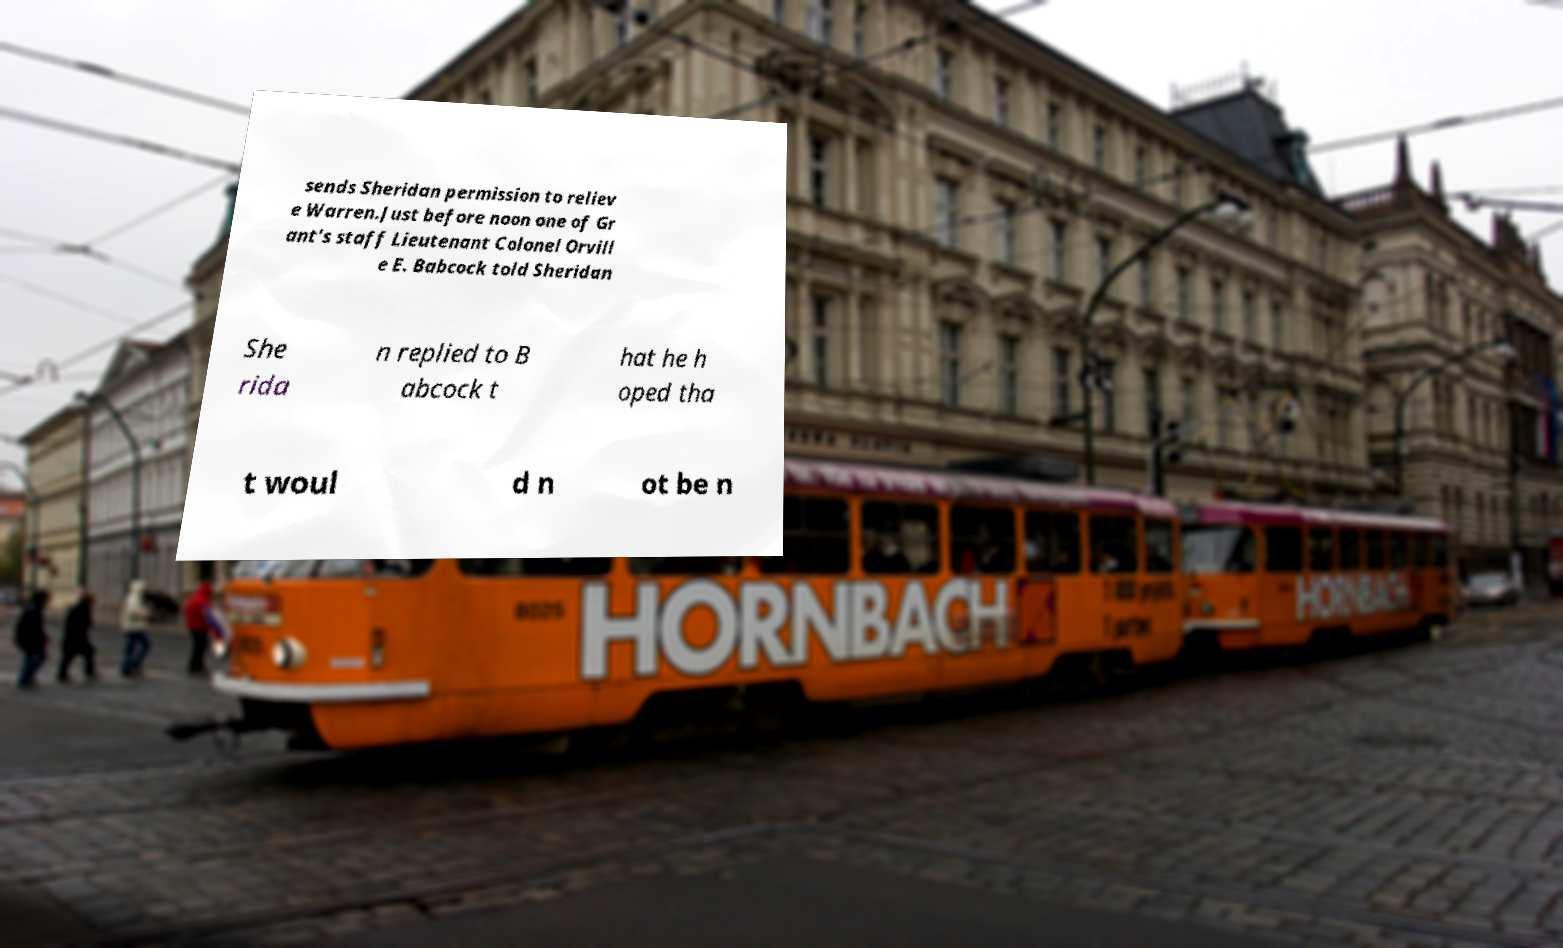What messages or text are displayed in this image? I need them in a readable, typed format. sends Sheridan permission to reliev e Warren.Just before noon one of Gr ant's staff Lieutenant Colonel Orvill e E. Babcock told Sheridan She rida n replied to B abcock t hat he h oped tha t woul d n ot be n 